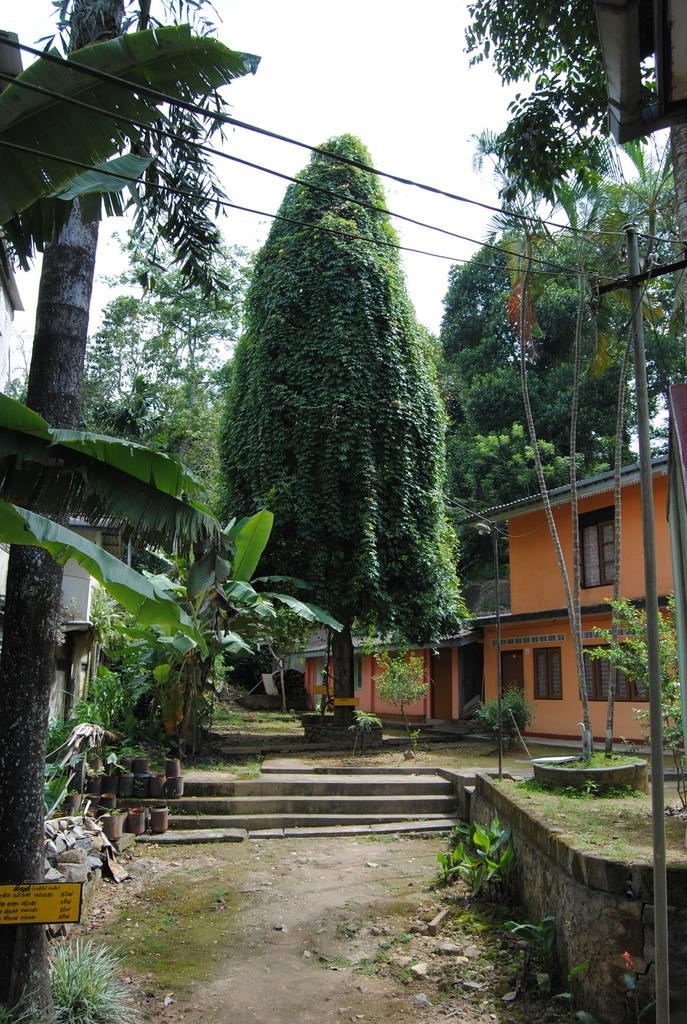What type of structure can be seen in the image? There is a building in the image. What natural elements are present in the image? There are trees, plants, and grass visible in the image. What architectural feature can be seen in the image? There are steps in the image. What is attached to a pole in the image? Wires are attached to a pole in the image. What part of the natural environment is visible in the background of the image? The sky is visible in the background of the image. What is the chance of the plant winning the lottery in the image? There is no plant present in the image, and therefore no such activity can be observed. Can you describe the tongue of the person in the image? There is no person present in the image, and therefore no tongue can be observed. 